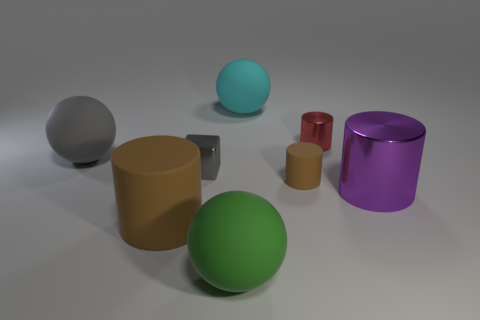Is there a green thing of the same size as the red cylinder?
Your answer should be compact. No. Do the rubber cylinder on the left side of the green sphere and the shiny object in front of the metallic block have the same color?
Offer a very short reply. No. How many matte objects are either small purple things or large gray things?
Your answer should be compact. 1. There is a big sphere on the right side of the rubber ball in front of the large gray thing; what number of large objects are on the right side of it?
Make the answer very short. 1. What is the size of the other brown cylinder that is made of the same material as the tiny brown cylinder?
Your answer should be compact. Large. How many other large metal cylinders have the same color as the large metallic cylinder?
Your answer should be very brief. 0. There is a rubber thing that is behind the red cylinder; does it have the same size as the big purple metal cylinder?
Provide a succinct answer. Yes. What is the color of the object that is on the right side of the small brown rubber cylinder and behind the small gray metallic object?
Your answer should be very brief. Red. What number of things are green rubber spheres or things in front of the cube?
Your answer should be compact. 4. There is a brown cylinder to the left of the big matte ball that is behind the tiny metal thing to the right of the tiny gray object; what is it made of?
Provide a short and direct response. Rubber. 